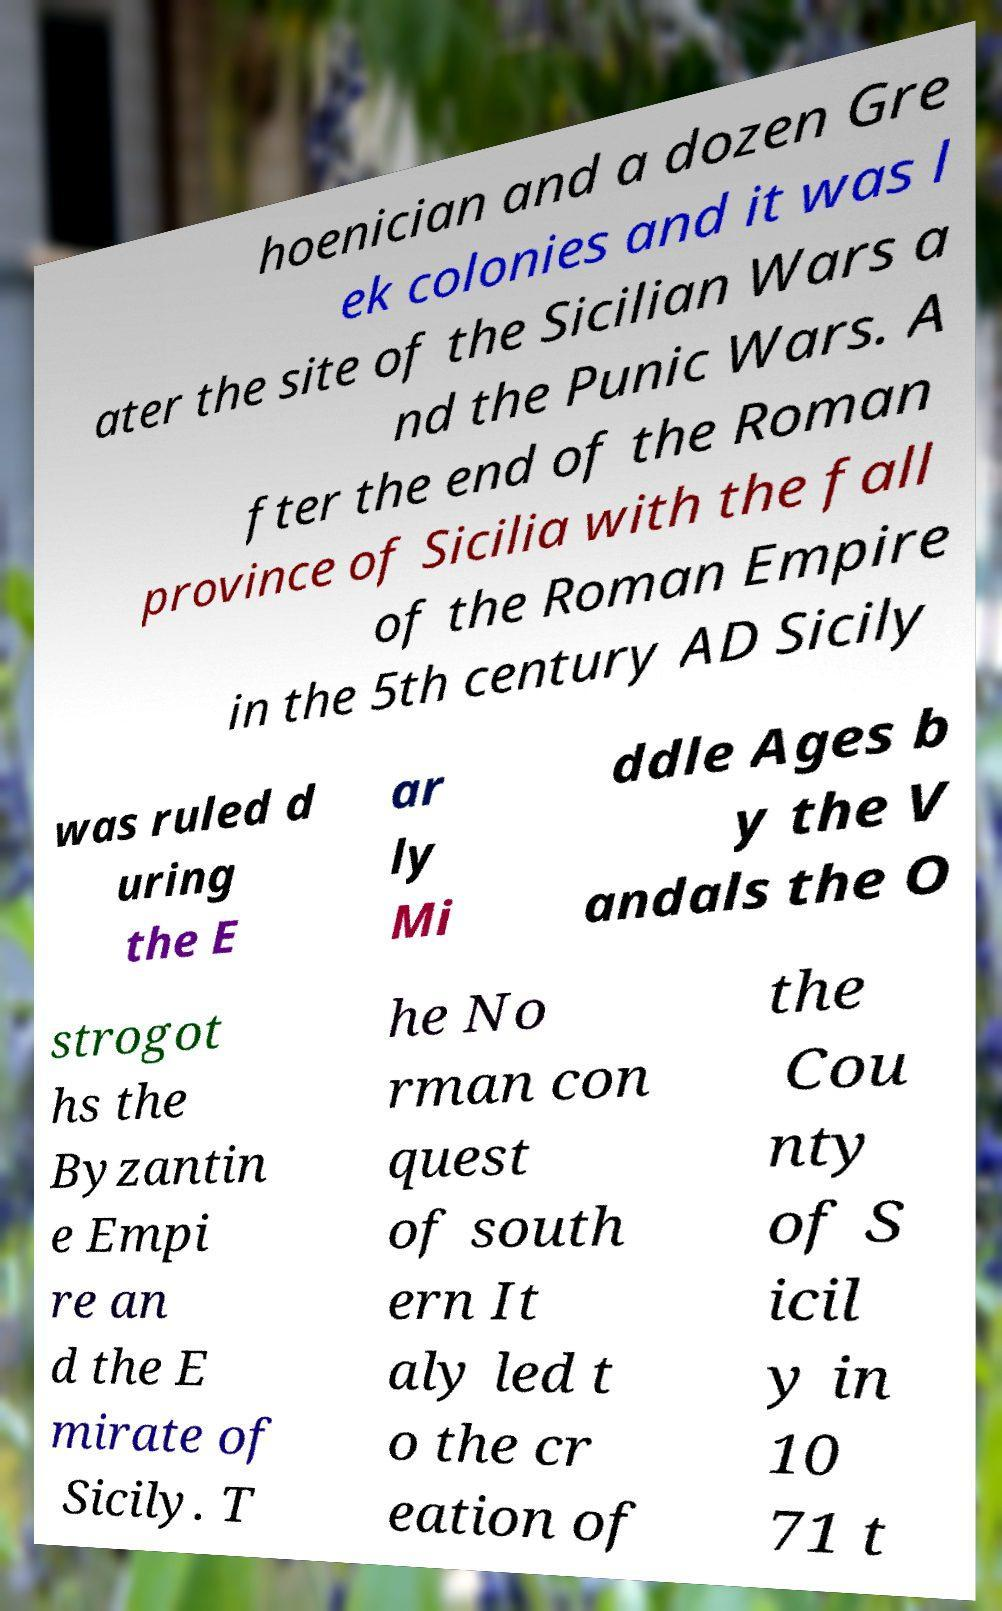There's text embedded in this image that I need extracted. Can you transcribe it verbatim? hoenician and a dozen Gre ek colonies and it was l ater the site of the Sicilian Wars a nd the Punic Wars. A fter the end of the Roman province of Sicilia with the fall of the Roman Empire in the 5th century AD Sicily was ruled d uring the E ar ly Mi ddle Ages b y the V andals the O strogot hs the Byzantin e Empi re an d the E mirate of Sicily. T he No rman con quest of south ern It aly led t o the cr eation of the Cou nty of S icil y in 10 71 t 